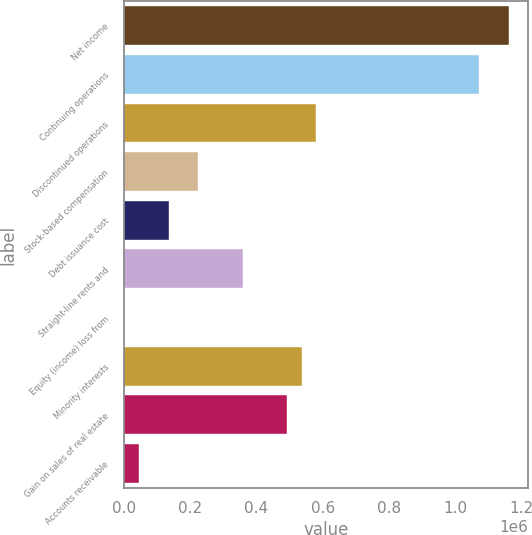Convert chart. <chart><loc_0><loc_0><loc_500><loc_500><bar_chart><fcel>Net income<fcel>Continuing operations<fcel>Discontinued operations<fcel>Stock-based compensation<fcel>Debt issuance cost<fcel>Straight-line rents and<fcel>Equity (income) loss from<fcel>Minority interests<fcel>Gain on sales of real estate<fcel>Accounts receivable<nl><fcel>1.1608e+06<fcel>1.07159e+06<fcel>580961<fcel>224138<fcel>134932<fcel>357946<fcel>1123<fcel>536358<fcel>491755<fcel>45725.9<nl></chart> 